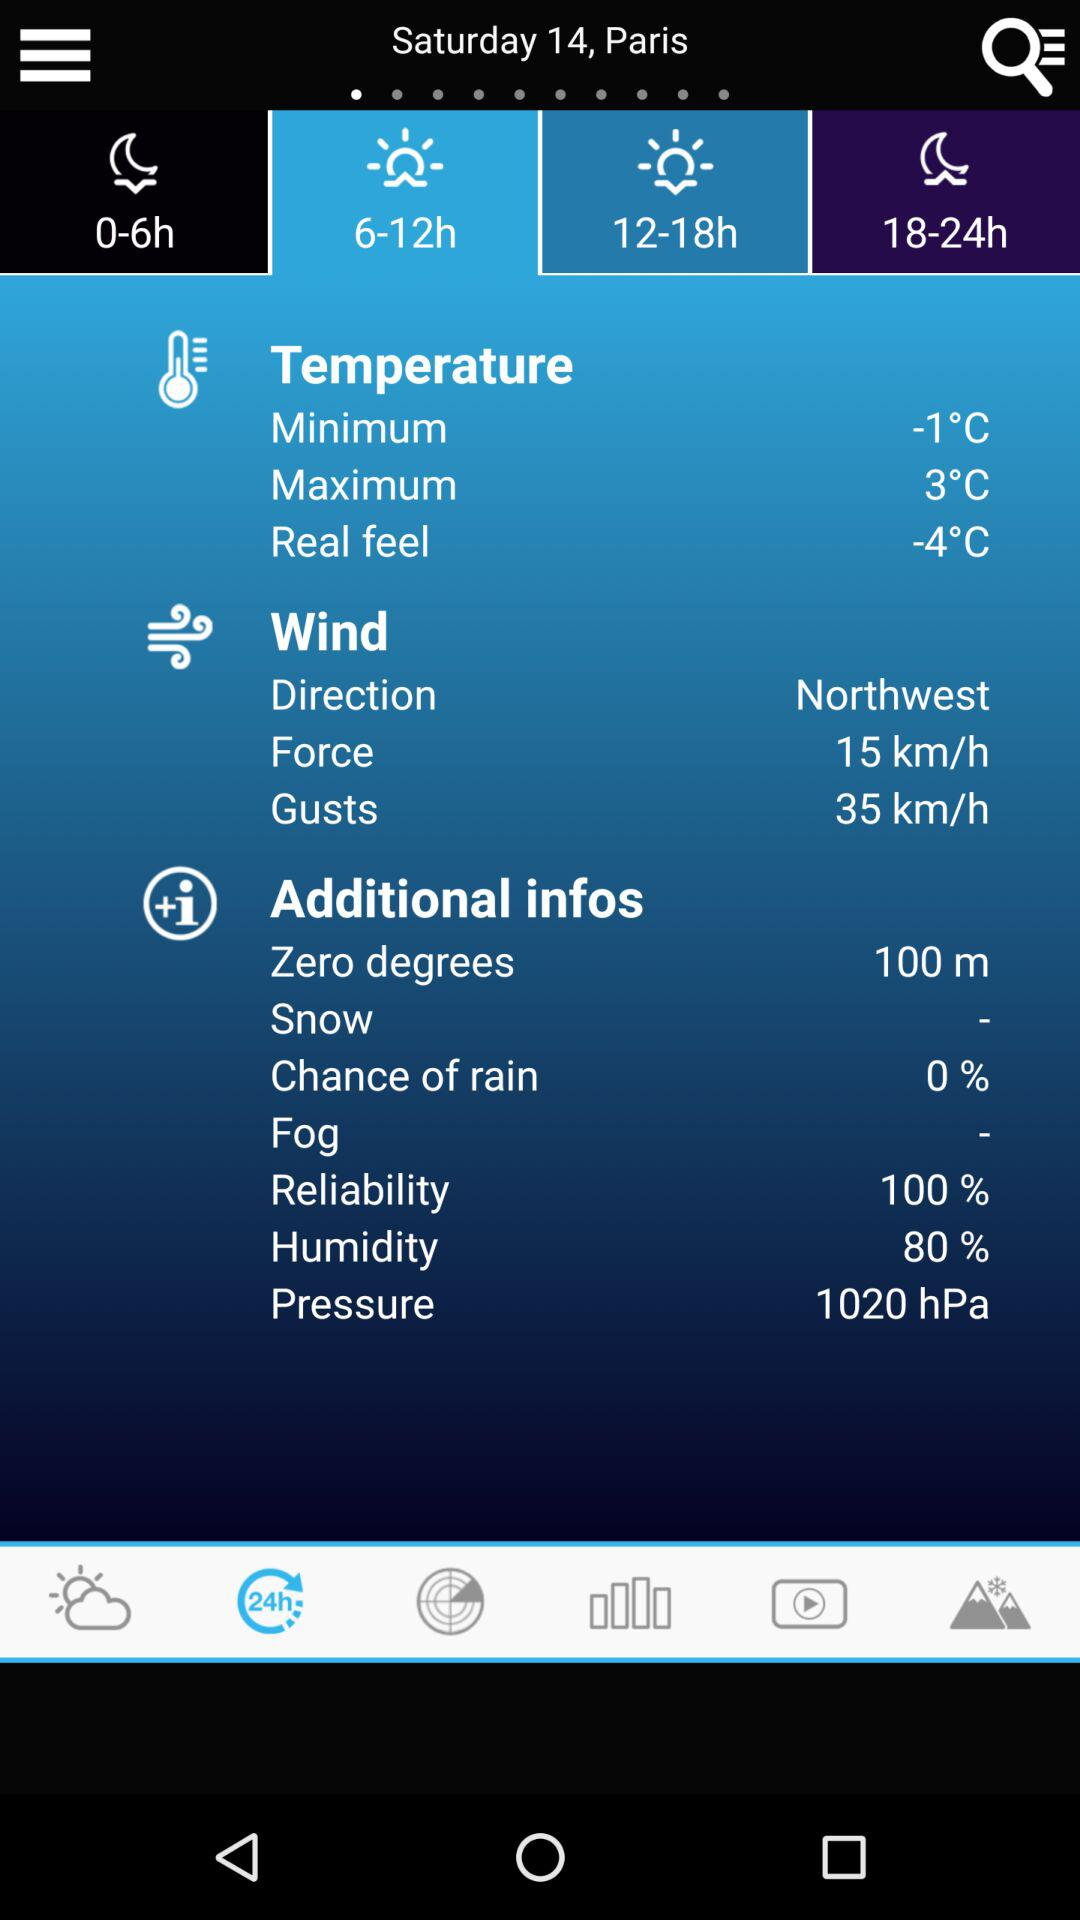What is the minimum temperature? The minimum temperature is -1°C. 